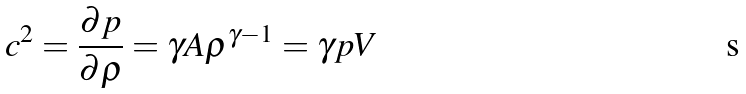Convert formula to latex. <formula><loc_0><loc_0><loc_500><loc_500>c ^ { 2 } = \frac { \partial p } { \partial \rho } = \gamma A \rho ^ { \gamma - 1 } = \gamma p V</formula> 